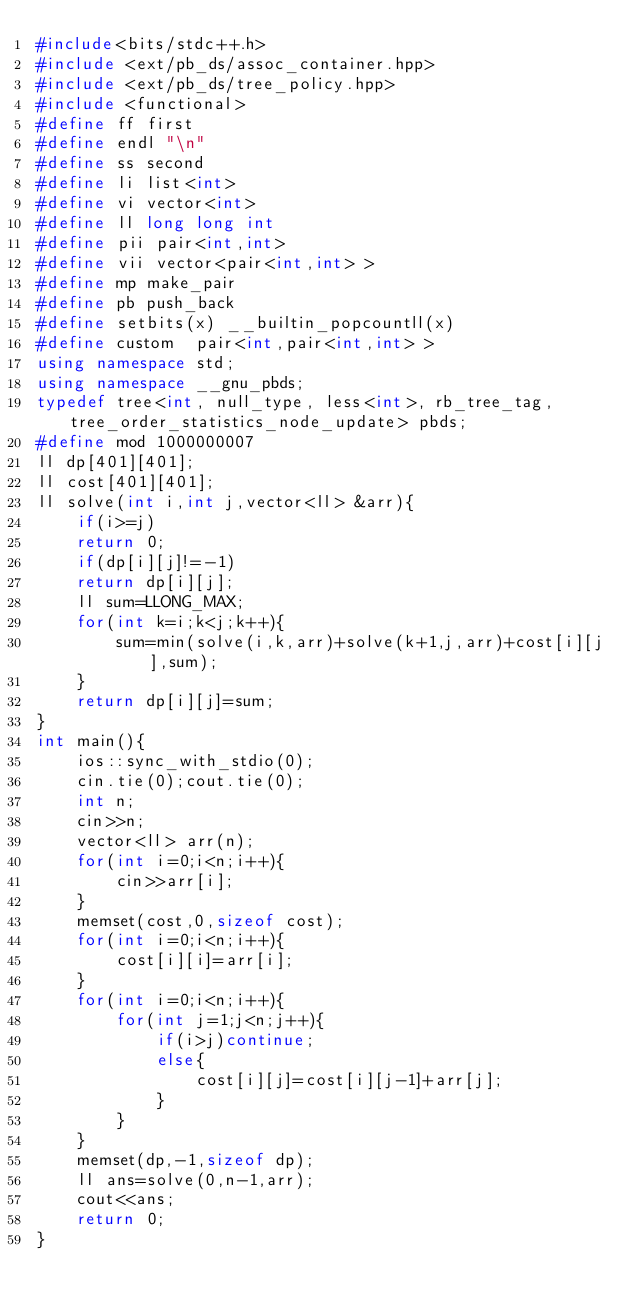<code> <loc_0><loc_0><loc_500><loc_500><_C++_>#include<bits/stdc++.h>
#include <ext/pb_ds/assoc_container.hpp>
#include <ext/pb_ds/tree_policy.hpp> 
#include <functional> 
#define ff first 
#define endl "\n"
#define ss second 
#define li list<int>
#define vi vector<int>
#define ll long long int
#define pii pair<int,int>
#define vii vector<pair<int,int> >
#define mp make_pair
#define pb push_back
#define setbits(x) __builtin_popcountll(x)
#define custom  pair<int,pair<int,int> >
using namespace std;
using namespace __gnu_pbds;
typedef tree<int, null_type, less<int>, rb_tree_tag,tree_order_statistics_node_update> pbds; 
#define mod 1000000007
ll dp[401][401];
ll cost[401][401];
ll solve(int i,int j,vector<ll> &arr){
    if(i>=j)
    return 0;
    if(dp[i][j]!=-1)
    return dp[i][j];
    ll sum=LLONG_MAX;
    for(int k=i;k<j;k++){
        sum=min(solve(i,k,arr)+solve(k+1,j,arr)+cost[i][j],sum);
    }
    return dp[i][j]=sum;
}
int main(){
    ios::sync_with_stdio(0);
    cin.tie(0);cout.tie(0);
    int n;
    cin>>n;
    vector<ll> arr(n);
    for(int i=0;i<n;i++){
        cin>>arr[i];
    }
    memset(cost,0,sizeof cost);
    for(int i=0;i<n;i++){
        cost[i][i]=arr[i];
    }
    for(int i=0;i<n;i++){
        for(int j=1;j<n;j++){
            if(i>j)continue;
            else{
                cost[i][j]=cost[i][j-1]+arr[j];
            }
        }
    }
    memset(dp,-1,sizeof dp);
    ll ans=solve(0,n-1,arr);
    cout<<ans;
    return 0;
}</code> 